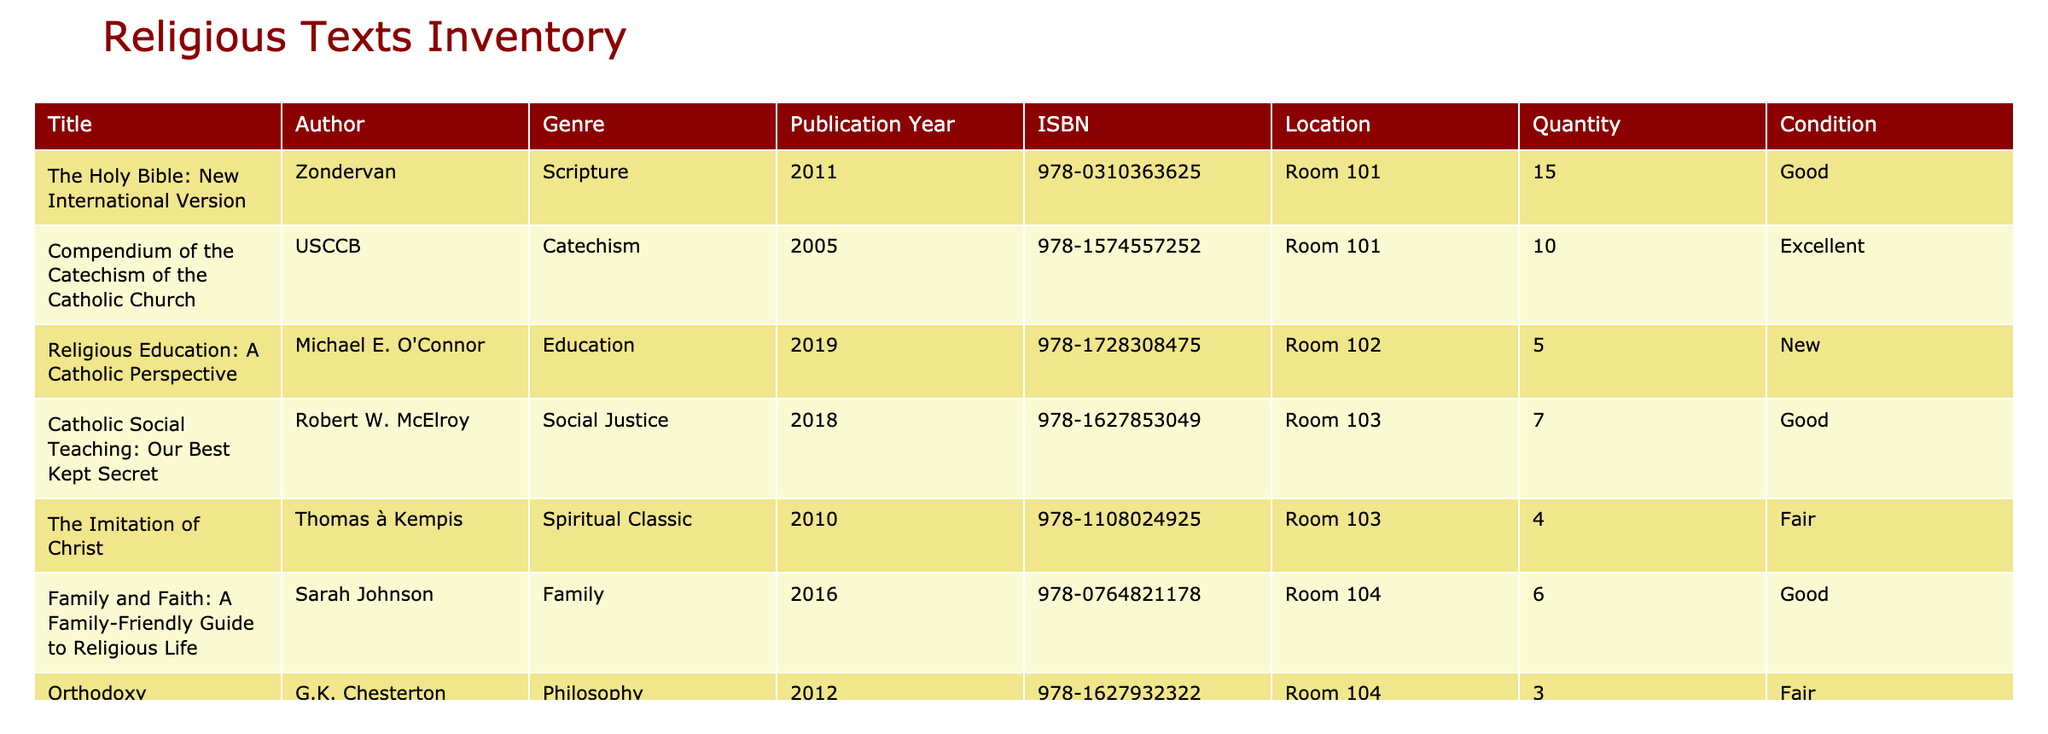What is the title of the scripture with the highest quantity available? The table shows that "The Holy Bible: New International Version" has a quantity of 15, which is the highest among all the texts listed.
Answer: The Holy Bible: New International Version How many total catechism resources are available in the library? There are two catechism resources: "Compendium of the Catechism of the Catholic Church" with a quantity of 10 and "Catechism of the Catholic Church" with a quantity of 5. Adding them gives 10 + 5 = 15.
Answer: 15 Is there a resource authored by G.K. Chesterton? The table lists "Orthodoxy" as a resource authored by G.K. Chesterton. Thus, the answer is yes.
Answer: Yes What is the publication year of "Family and Faith: A Family-Friendly Guide to Religious Life"? Referring to the table, "Family and Faith: A Family-Friendly Guide to Religious Life" was published in 2016 as explicitly indicated in the publication year column.
Answer: 2016 How many books in total are categorized under spiritual classics and social justice? The table shows "The Imitation of Christ" as a spiritual classic with a quantity of 4 and "Catholic Social Teaching: Our Best Kept Secret" under social justice with a quantity of 7. Adding them gives 4 + 7 = 11.
Answer: 11 What condition is "Orthodoxy" by G.K. Chesterton in? The condition of "Orthodoxy" is listed as fair according to the table.
Answer: Fair Can you find any new resources added to the library? "Religious Education: A Catholic Perspective" is listed as a new resource, making the answer yes.
Answer: Yes What is the total number of religious texts available in Room 101? In Room 101, there are "The Holy Bible: New International Version" with a quantity of 15 and "Compendium of the Catechism of the Catholic Church" with a quantity of 10. Adding these gives 15 + 10 = 25.
Answer: 25 Which genre has the highest quantity of resources available? Comparing all genres, the scripture genre has 15 texts ("The Holy Bible: New International Version"), while catechism has 15, education has 5, social justice has 7, family has 6, philosophy has 3, and spiritual classic has 4. Here, scripture and catechism both have the highest quantity. Since we are looking for unique maximums, scripture qualifies as the one with the highest individual count.
Answer: Scripture 